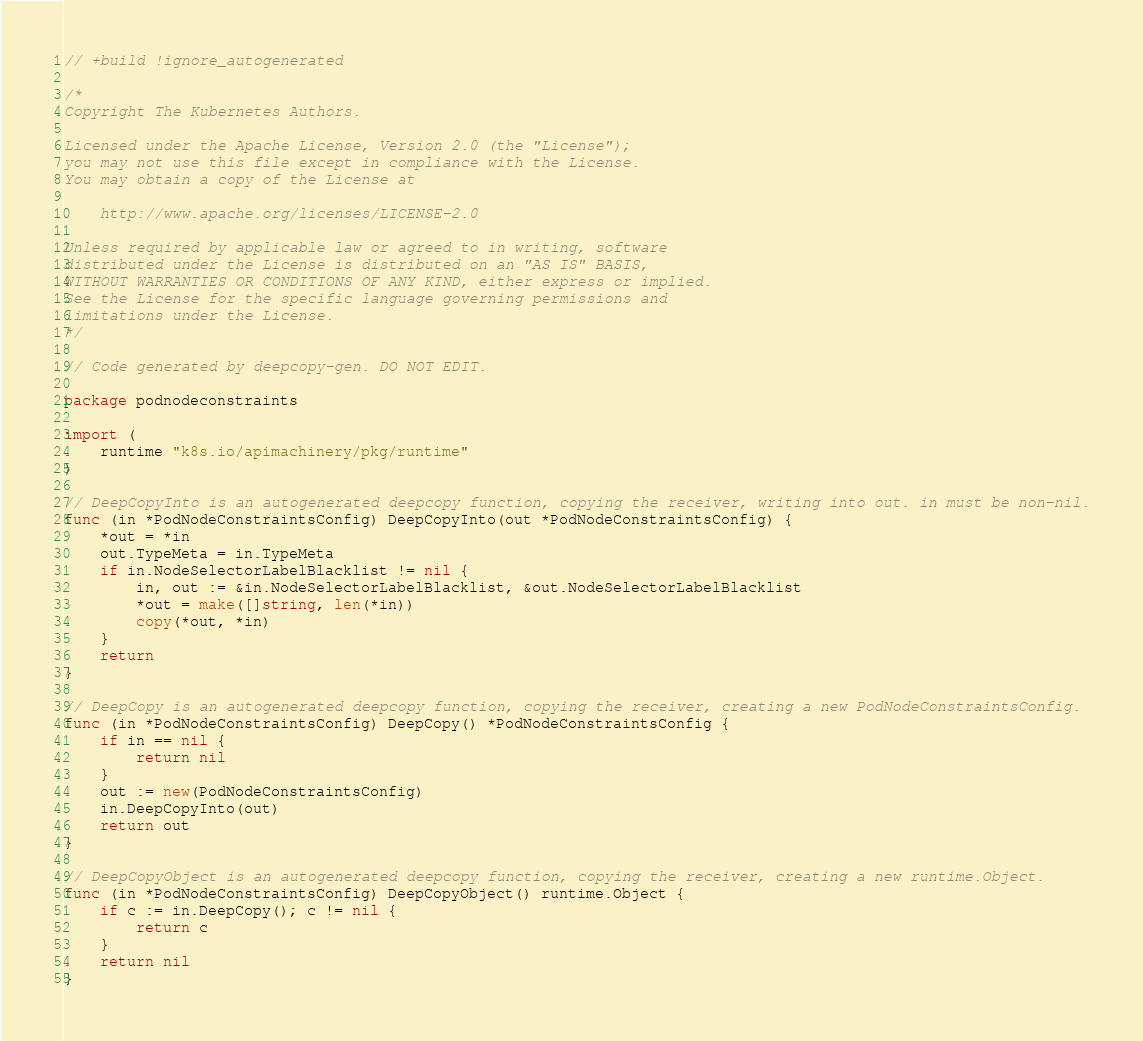<code> <loc_0><loc_0><loc_500><loc_500><_Go_>// +build !ignore_autogenerated

/*
Copyright The Kubernetes Authors.

Licensed under the Apache License, Version 2.0 (the "License");
you may not use this file except in compliance with the License.
You may obtain a copy of the License at

    http://www.apache.org/licenses/LICENSE-2.0

Unless required by applicable law or agreed to in writing, software
distributed under the License is distributed on an "AS IS" BASIS,
WITHOUT WARRANTIES OR CONDITIONS OF ANY KIND, either express or implied.
See the License for the specific language governing permissions and
limitations under the License.
*/

// Code generated by deepcopy-gen. DO NOT EDIT.

package podnodeconstraints

import (
	runtime "k8s.io/apimachinery/pkg/runtime"
)

// DeepCopyInto is an autogenerated deepcopy function, copying the receiver, writing into out. in must be non-nil.
func (in *PodNodeConstraintsConfig) DeepCopyInto(out *PodNodeConstraintsConfig) {
	*out = *in
	out.TypeMeta = in.TypeMeta
	if in.NodeSelectorLabelBlacklist != nil {
		in, out := &in.NodeSelectorLabelBlacklist, &out.NodeSelectorLabelBlacklist
		*out = make([]string, len(*in))
		copy(*out, *in)
	}
	return
}

// DeepCopy is an autogenerated deepcopy function, copying the receiver, creating a new PodNodeConstraintsConfig.
func (in *PodNodeConstraintsConfig) DeepCopy() *PodNodeConstraintsConfig {
	if in == nil {
		return nil
	}
	out := new(PodNodeConstraintsConfig)
	in.DeepCopyInto(out)
	return out
}

// DeepCopyObject is an autogenerated deepcopy function, copying the receiver, creating a new runtime.Object.
func (in *PodNodeConstraintsConfig) DeepCopyObject() runtime.Object {
	if c := in.DeepCopy(); c != nil {
		return c
	}
	return nil
}
</code> 